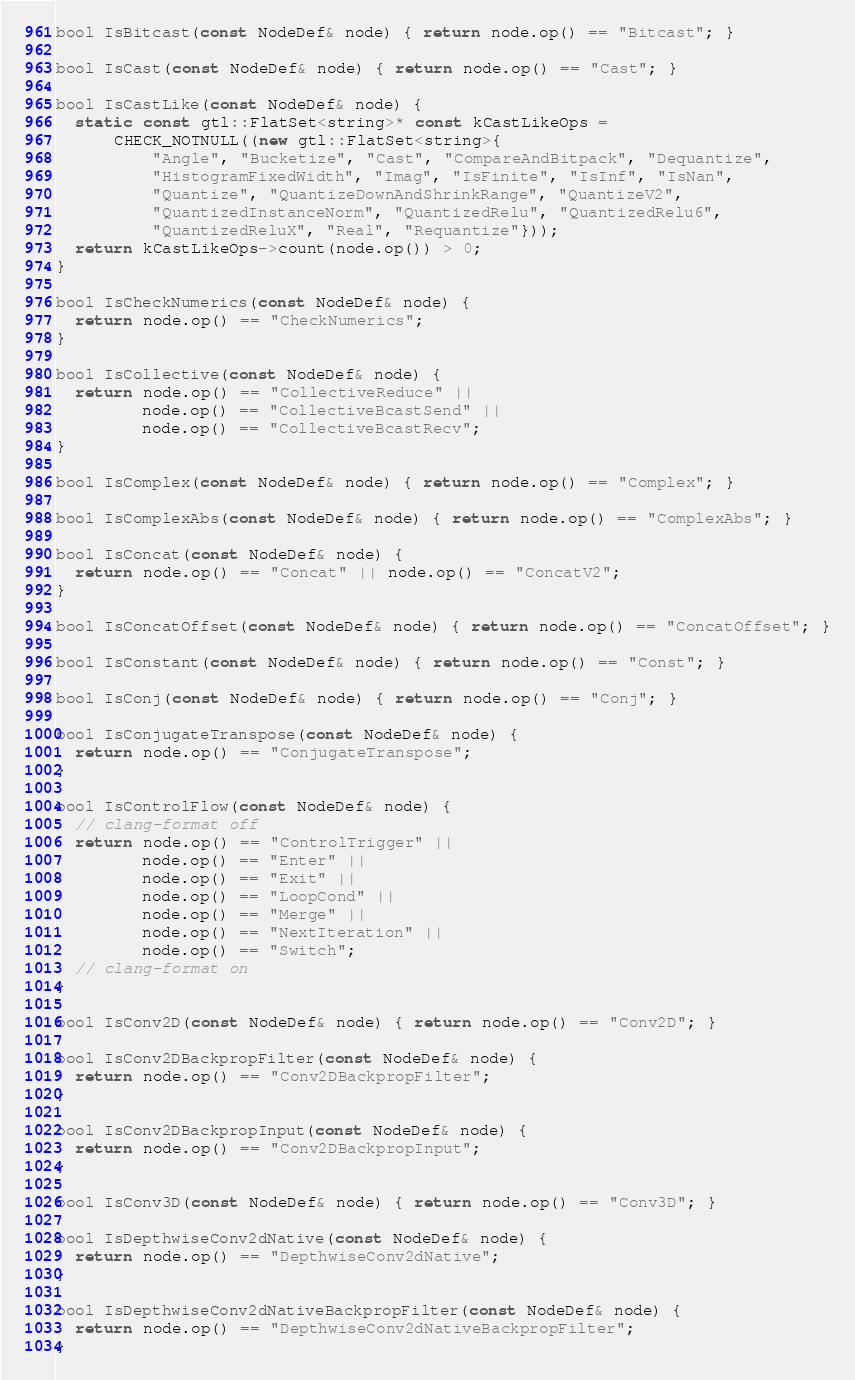<code> <loc_0><loc_0><loc_500><loc_500><_C++_>bool IsBitcast(const NodeDef& node) { return node.op() == "Bitcast"; }

bool IsCast(const NodeDef& node) { return node.op() == "Cast"; }

bool IsCastLike(const NodeDef& node) {
  static const gtl::FlatSet<string>* const kCastLikeOps =
      CHECK_NOTNULL((new gtl::FlatSet<string>{
          "Angle", "Bucketize", "Cast", "CompareAndBitpack", "Dequantize",
          "HistogramFixedWidth", "Imag", "IsFinite", "IsInf", "IsNan",
          "Quantize", "QuantizeDownAndShrinkRange", "QuantizeV2",
          "QuantizedInstanceNorm", "QuantizedRelu", "QuantizedRelu6",
          "QuantizedReluX", "Real", "Requantize"}));
  return kCastLikeOps->count(node.op()) > 0;
}

bool IsCheckNumerics(const NodeDef& node) {
  return node.op() == "CheckNumerics";
}

bool IsCollective(const NodeDef& node) {
  return node.op() == "CollectiveReduce" ||
         node.op() == "CollectiveBcastSend" ||
         node.op() == "CollectiveBcastRecv";
}

bool IsComplex(const NodeDef& node) { return node.op() == "Complex"; }

bool IsComplexAbs(const NodeDef& node) { return node.op() == "ComplexAbs"; }

bool IsConcat(const NodeDef& node) {
  return node.op() == "Concat" || node.op() == "ConcatV2";
}

bool IsConcatOffset(const NodeDef& node) { return node.op() == "ConcatOffset"; }

bool IsConstant(const NodeDef& node) { return node.op() == "Const"; }

bool IsConj(const NodeDef& node) { return node.op() == "Conj"; }

bool IsConjugateTranspose(const NodeDef& node) {
  return node.op() == "ConjugateTranspose";
}

bool IsControlFlow(const NodeDef& node) {
  // clang-format off
  return node.op() == "ControlTrigger" ||
         node.op() == "Enter" ||
         node.op() == "Exit" ||
         node.op() == "LoopCond" ||
         node.op() == "Merge" ||
         node.op() == "NextIteration" ||
         node.op() == "Switch";
  // clang-format on
}

bool IsConv2D(const NodeDef& node) { return node.op() == "Conv2D"; }

bool IsConv2DBackpropFilter(const NodeDef& node) {
  return node.op() == "Conv2DBackpropFilter";
}

bool IsConv2DBackpropInput(const NodeDef& node) {
  return node.op() == "Conv2DBackpropInput";
}

bool IsConv3D(const NodeDef& node) { return node.op() == "Conv3D"; }

bool IsDepthwiseConv2dNative(const NodeDef& node) {
  return node.op() == "DepthwiseConv2dNative";
}

bool IsDepthwiseConv2dNativeBackpropFilter(const NodeDef& node) {
  return node.op() == "DepthwiseConv2dNativeBackpropFilter";
}
</code> 